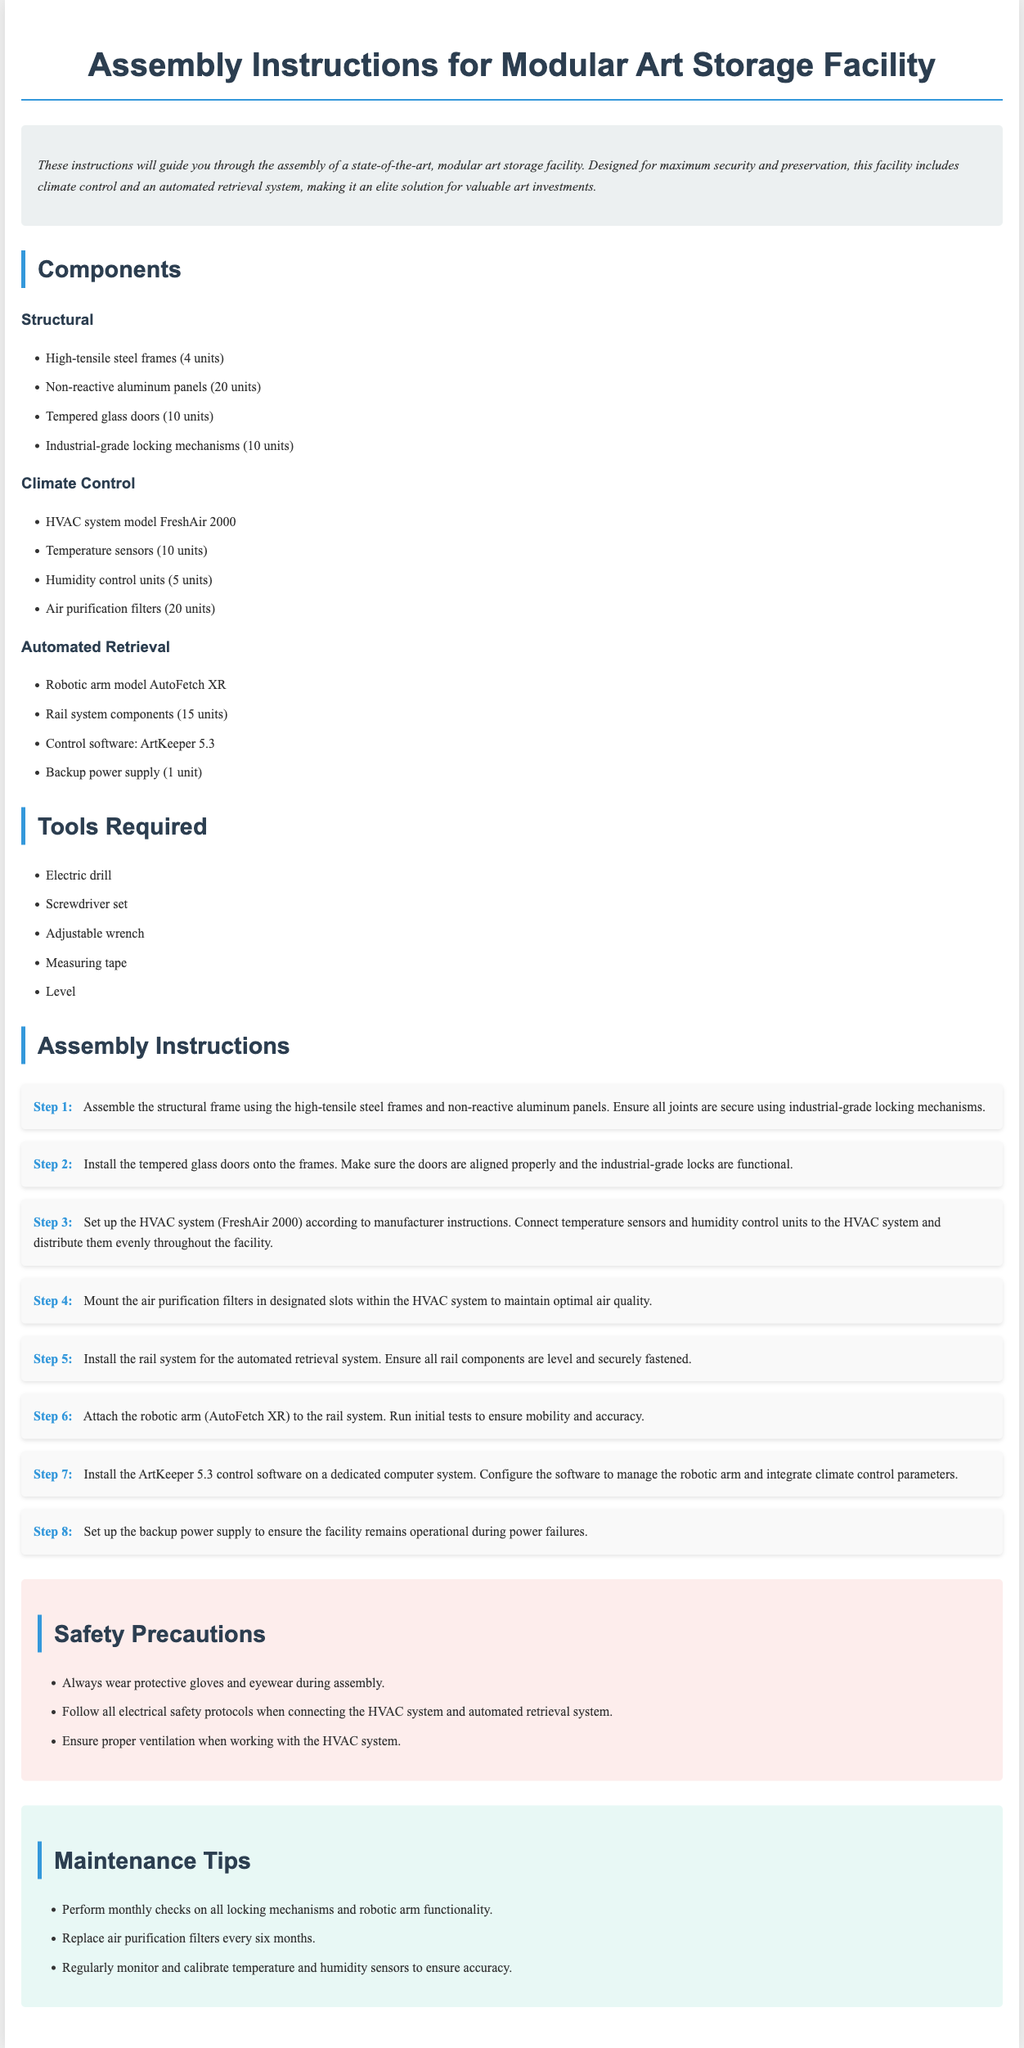What is the model of the HVAC system? The HVAC system model mentioned in the document is FreshAir 2000.
Answer: FreshAir 2000 How many tempered glass doors are required? The document specifies the use of 10 tempered glass doors in the assembly.
Answer: 10 units What component is used for air purification? The air purification filters are mentioned as a component in the climate control section.
Answer: Air purification filters What step involves installing the robotic arm? The installation of the robotic arm is detailed in Step 6 of the assembly instructions.
Answer: Step 6 How often should the air purification filters be replaced? Maintenance tips indicate that air purification filters should be replaced every six months.
Answer: Every six months What should be worn during assembly for safety? The safety precautions section advises wearing protective gloves and eyewear during assembly.
Answer: Protective gloves and eyewear How many units of humidity control units are included? In the climate control components, it states that there are 5 humidity control units required.
Answer: 5 units What type of software is used for control? The control software specified in the document is ArtKeeper 5.3.
Answer: ArtKeeper 5.3 